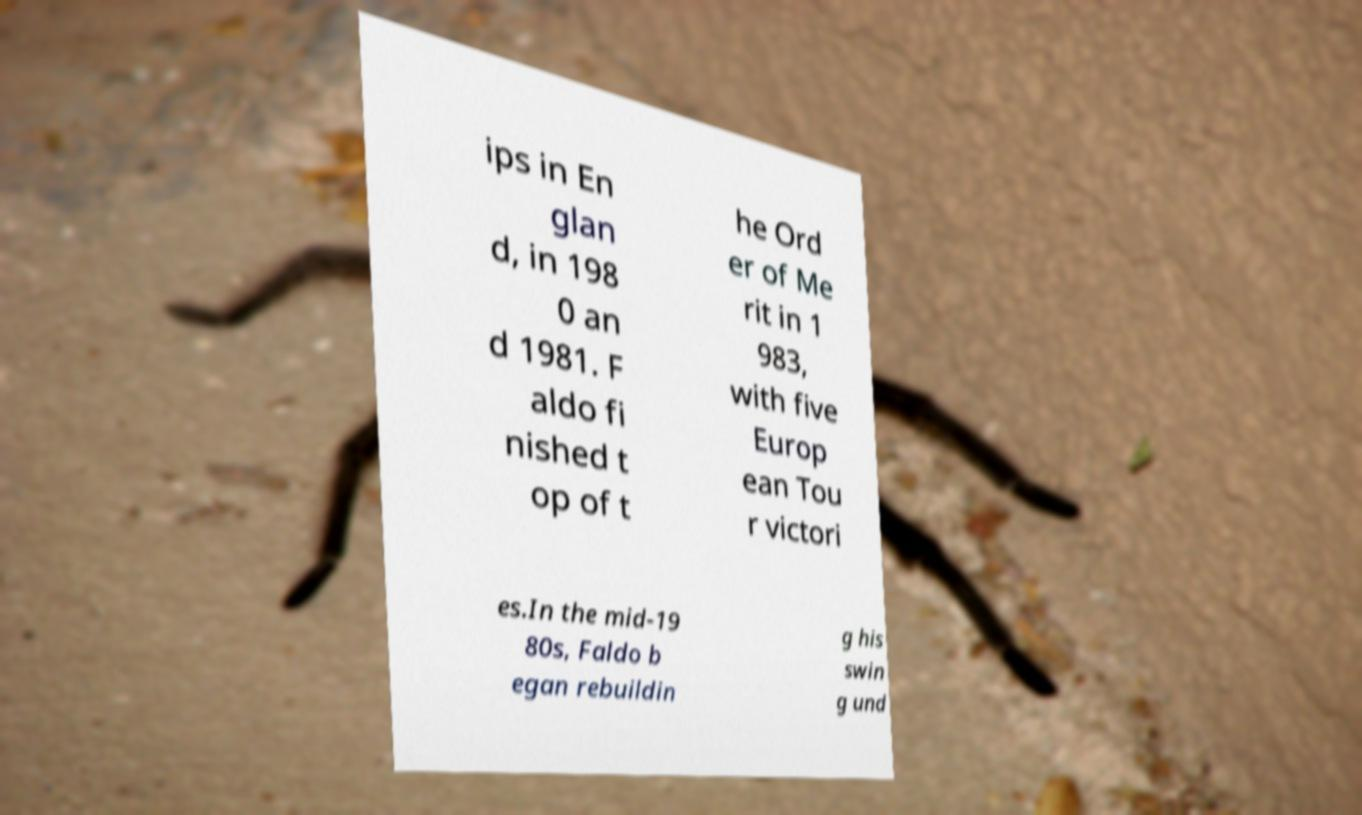There's text embedded in this image that I need extracted. Can you transcribe it verbatim? ips in En glan d, in 198 0 an d 1981. F aldo fi nished t op of t he Ord er of Me rit in 1 983, with five Europ ean Tou r victori es.In the mid-19 80s, Faldo b egan rebuildin g his swin g und 